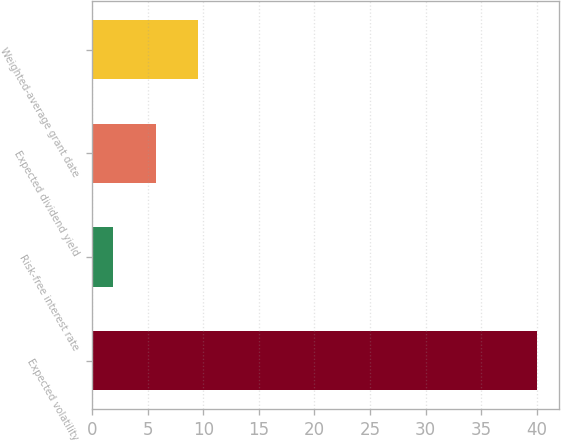Convert chart. <chart><loc_0><loc_0><loc_500><loc_500><bar_chart><fcel>Expected volatility<fcel>Risk-free interest rate<fcel>Expected dividend yield<fcel>Weighted-average grant date<nl><fcel>40<fcel>1.9<fcel>5.71<fcel>9.52<nl></chart> 